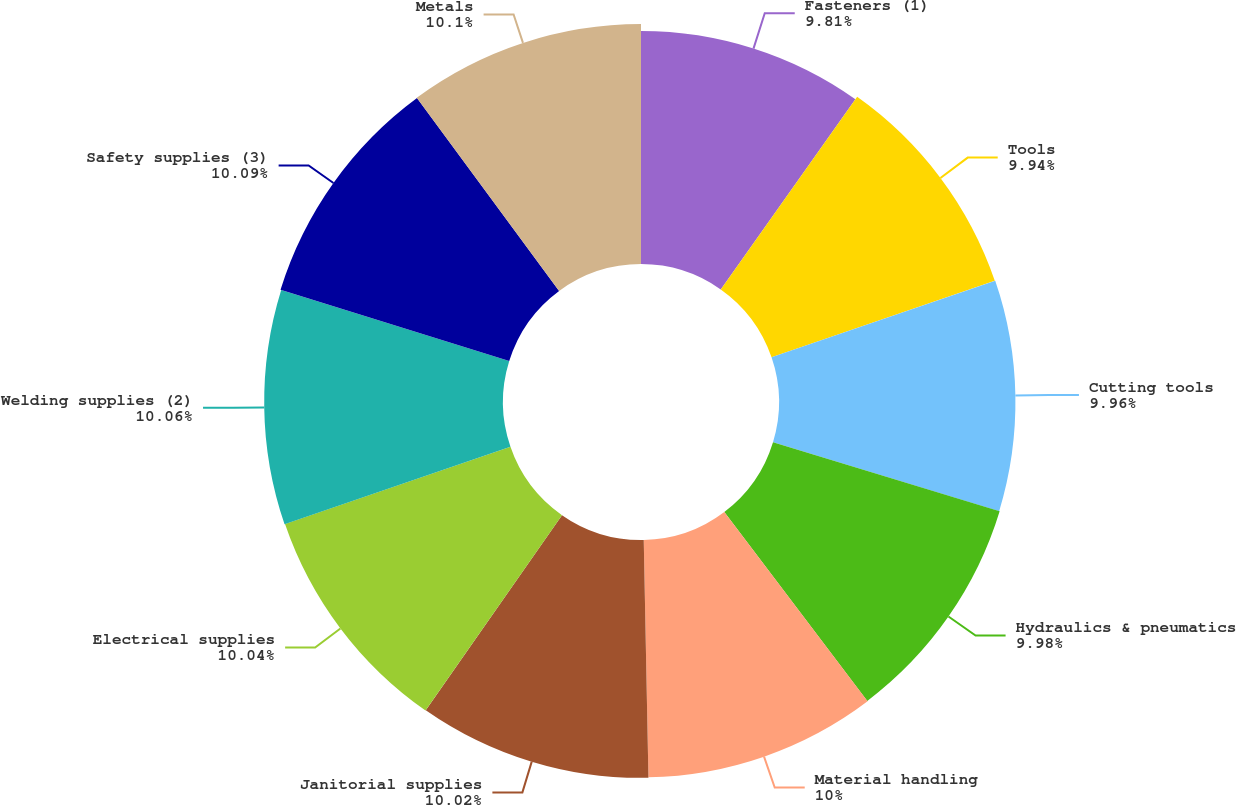<chart> <loc_0><loc_0><loc_500><loc_500><pie_chart><fcel>Fasteners (1)<fcel>Tools<fcel>Cutting tools<fcel>Hydraulics & pneumatics<fcel>Material handling<fcel>Janitorial supplies<fcel>Electrical supplies<fcel>Welding supplies (2)<fcel>Safety supplies (3)<fcel>Metals<nl><fcel>9.81%<fcel>9.94%<fcel>9.96%<fcel>9.98%<fcel>10.0%<fcel>10.02%<fcel>10.04%<fcel>10.06%<fcel>10.09%<fcel>10.11%<nl></chart> 